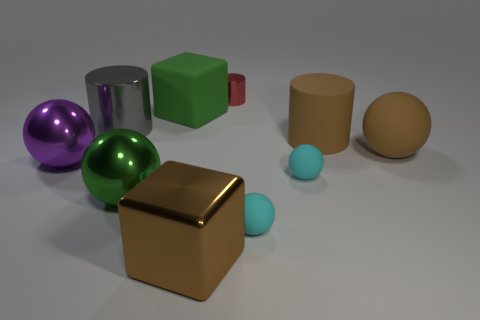Are any small cyan rubber balls visible? yes 